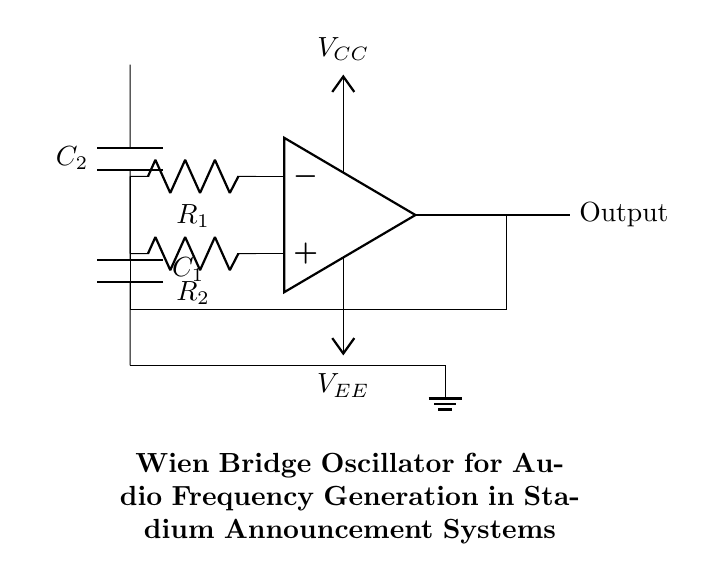What type of oscillator is this circuit? The circuit is a Wien Bridge Oscillator, which is indicated by the specific arrangement of resistors and capacitors that set the frequency of oscillation.
Answer: Wien Bridge Oscillator What are the values of R1 and R2? The values for R1 and R2 are not specified in the code but are typically equal for the oscillator to maintain balance and ensure oscillation; often these are designed with a value ratio for the circuit.
Answer: Not specified How many capacitors are present in the circuit? There are two capacitors present in the circuit, labeled C1 and C2, connecting the resistors and contributing to the oscillator's frequency generation.
Answer: Two What is the function of the operational amplifier in this circuit? The operational amplifier amplifies the signals and creates the necessary feedback for oscillation by maintaining the conditions required for a stable oscillation output.
Answer: Amplification What is the power supply voltage labeled as? The power supply voltages are labeled as VCC and VEE, representing the positive and negative supply voltages that power the operational amplifier in the circuit.
Answer: VCC and VEE What component ensures feedback in the circuit? The feedback in the circuit is ensured by the connection from the output of the operational amplifier back to the input through the resistors and capacitors, forming the necessary feedback loop.
Answer: Feedback loop What determines the frequency of oscillation in this oscillator? The frequency of oscillation in a Wien Bridge Oscillator is determined by the resistor and capacitor values in the circuit; specifically, the resistance from R1 and R2 and the capacitance from C1 and C2.
Answer: Resistor and capacitor values 